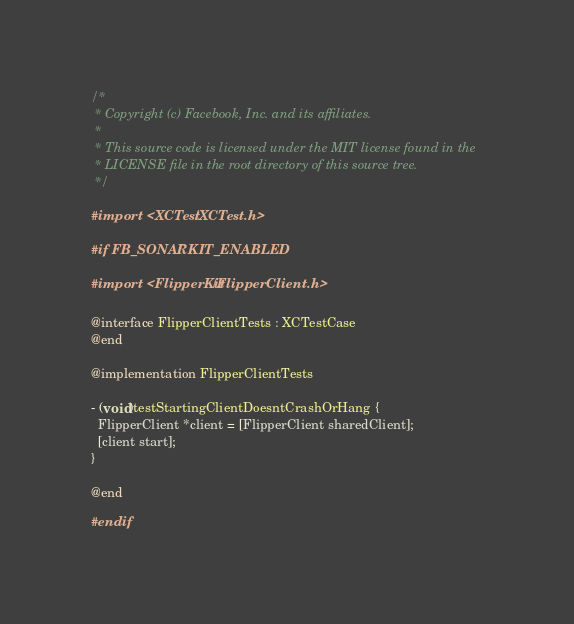Convert code to text. <code><loc_0><loc_0><loc_500><loc_500><_ObjectiveC_>/*
 * Copyright (c) Facebook, Inc. and its affiliates.
 *
 * This source code is licensed under the MIT license found in the
 * LICENSE file in the root directory of this source tree.
 */

#import <XCTest/XCTest.h>

#if FB_SONARKIT_ENABLED

#import <FlipperKit/FlipperClient.h>

@interface FlipperClientTests : XCTestCase
@end

@implementation FlipperClientTests

- (void)testStartingClientDoesntCrashOrHang {
  FlipperClient *client = [FlipperClient sharedClient];
  [client start];
}

@end

#endif
</code> 